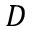Convert formula to latex. <formula><loc_0><loc_0><loc_500><loc_500>D</formula> 